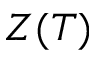<formula> <loc_0><loc_0><loc_500><loc_500>Z ( T )</formula> 